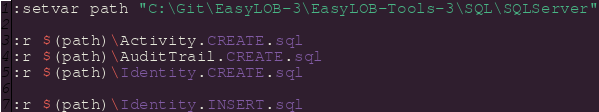Convert code to text. <code><loc_0><loc_0><loc_500><loc_500><_SQL_>:setvar path "C:\Git\EasyLOB-3\EasyLOB-Tools-3\SQL\SQLServer"

:r $(path)\Activity.CREATE.sql
:r $(path)\AuditTrail.CREATE.sql
:r $(path)\Identity.CREATE.sql

:r $(path)\Identity.INSERT.sql
</code> 